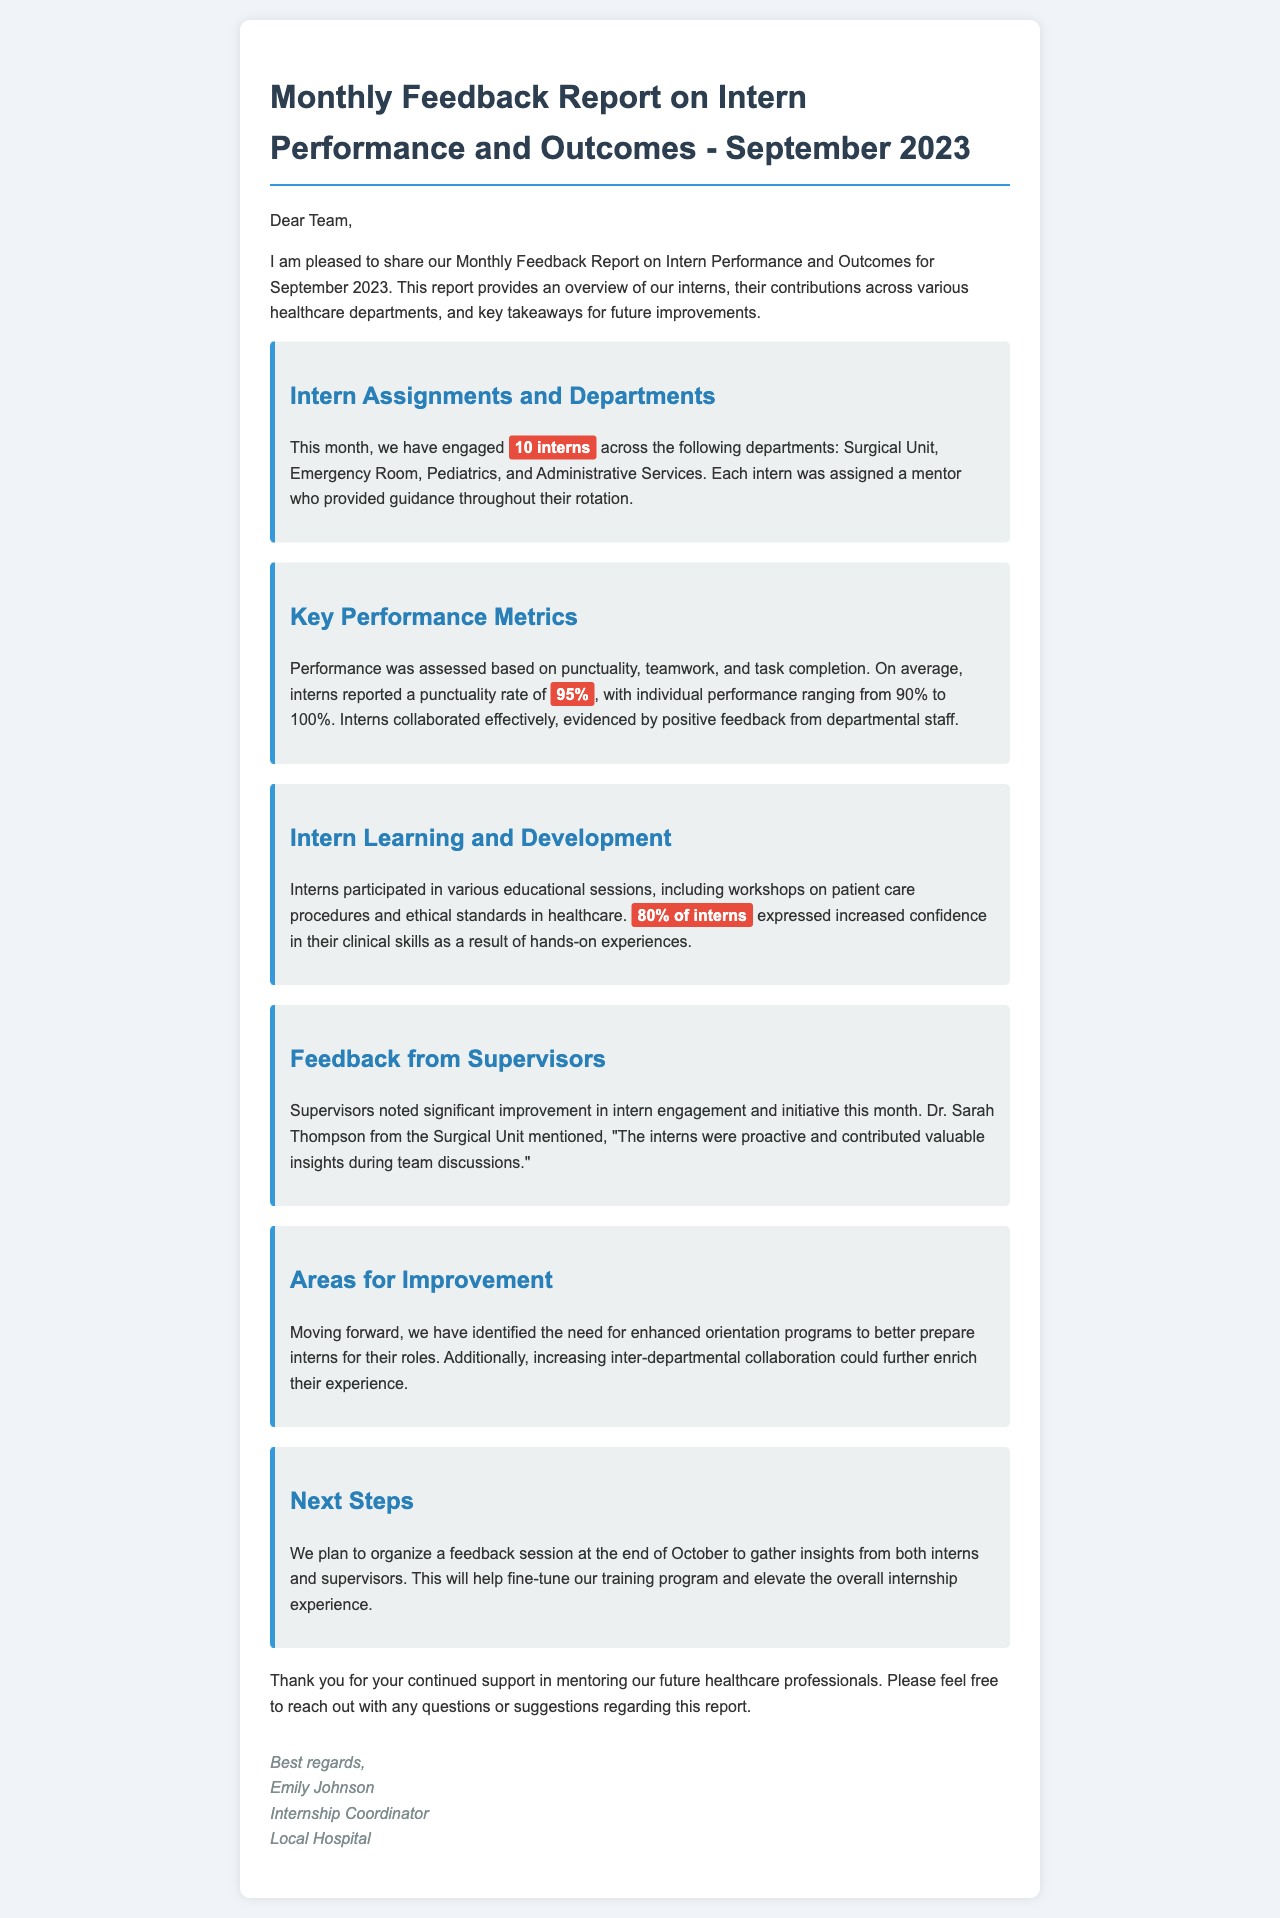what is the title of the document? The title of the document is stated in the header section of the report.
Answer: Monthly Feedback Report on Intern Performance and Outcomes - September 2023 how many interns were engaged this month? The document provides a specific number of interns involved in various departments.
Answer: 10 interns what was the average punctuality rate of the interns? The average punctuality rate is highlighted in the report as part of the performance metrics.
Answer: 95% which department had a supervisor named Dr. Sarah Thompson? The document mentions the name of the supervisor and their corresponding department in the feedback section.
Answer: Surgical Unit what percentage of interns expressed increased confidence in their clinical skills? This percentage is provided in the learning and development section of the report.
Answer: 80% what area for improvement was identified regarding orientation programs? The document specifies a need for enhanced orientation programs which is mentioned in the areas for improvement section.
Answer: Enhanced orientation programs when is the planned feedback session to gather insights? The document states the timeline for the feedback session at the end of October.
Answer: End of October what was noted about interns' engagement and initiative by supervisors? Supervisors provided comments on intern performance in the feedback section of the report.
Answer: Significant improvement 